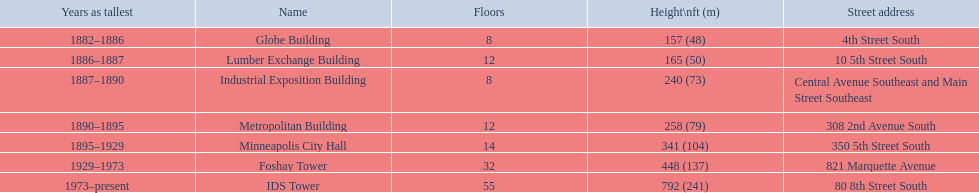How many floors does the lumber exchange building have? 12. What other building has 12 floors? Metropolitan Building. 